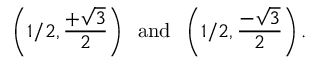Convert formula to latex. <formula><loc_0><loc_0><loc_500><loc_500>\left ( 1 / 2 , { \frac { + { \sqrt { 3 } } } { 2 } } \right ) \, a n d \, \left ( 1 / 2 , { \frac { - { \sqrt { 3 } } } { 2 } } \right ) .</formula> 